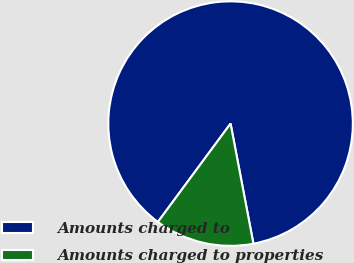Convert chart to OTSL. <chart><loc_0><loc_0><loc_500><loc_500><pie_chart><fcel>Amounts charged to<fcel>Amounts charged to properties<nl><fcel>86.88%<fcel>13.12%<nl></chart> 